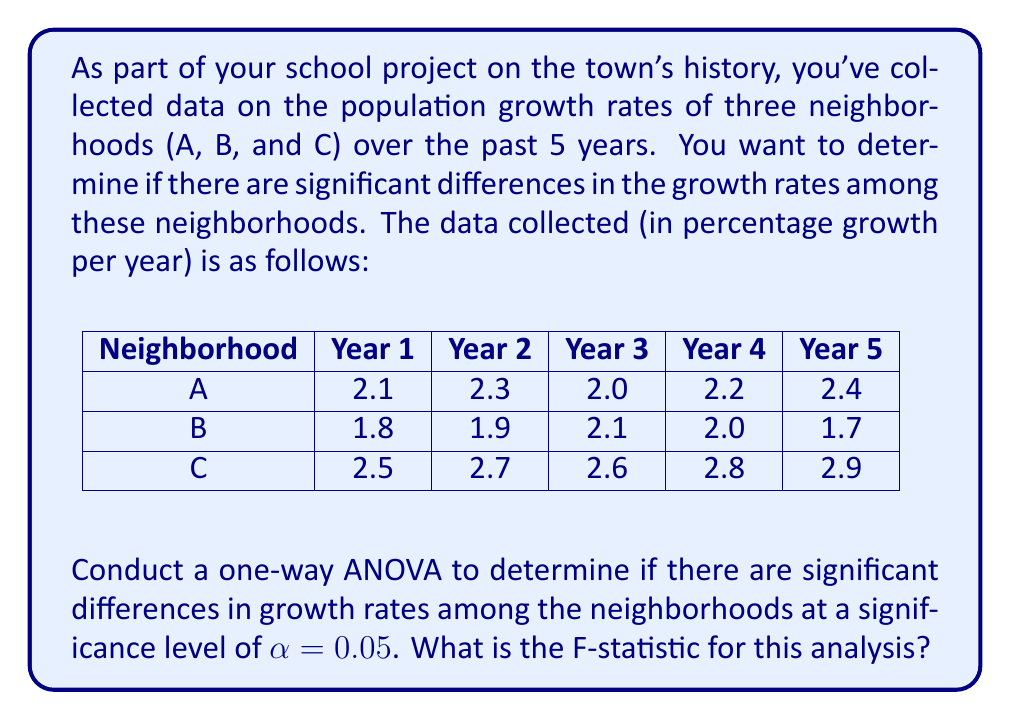Can you solve this math problem? To conduct a one-way ANOVA, we need to follow these steps:

1) Calculate the mean for each group (neighborhood):
   $\bar{x}_A = \frac{2.1 + 2.3 + 2.0 + 2.2 + 2.4}{5} = 2.2$
   $\bar{x}_B = \frac{1.8 + 1.9 + 2.1 + 2.0 + 1.7}{5} = 1.9$
   $\bar{x}_C = \frac{2.5 + 2.7 + 2.6 + 2.8 + 2.9}{5} = 2.7$

2) Calculate the grand mean:
   $\bar{x} = \frac{2.2 + 1.9 + 2.7}{3} = 2.267$

3) Calculate the Sum of Squares Between (SSB):
   $SSB = 5[(2.2 - 2.267)^2 + (1.9 - 2.267)^2 + (2.7 - 2.267)^2] = 1.6333$

4) Calculate the Sum of Squares Within (SSW):
   $SSW_A = (2.1 - 2.2)^2 + (2.3 - 2.2)^2 + (2.0 - 2.2)^2 + (2.2 - 2.2)^2 + (2.4 - 2.2)^2 = 0.12$
   $SSW_B = (1.8 - 1.9)^2 + (1.9 - 1.9)^2 + (2.1 - 1.9)^2 + (2.0 - 1.9)^2 + (1.7 - 1.9)^2 = 0.12$
   $SSW_C = (2.5 - 2.7)^2 + (2.7 - 2.7)^2 + (2.6 - 2.7)^2 + (2.8 - 2.7)^2 + (2.9 - 2.7)^2 = 0.12$
   $SSW = SSW_A + SSW_B + SSW_C = 0.36$

5) Calculate degrees of freedom:
   $df_{between} = k - 1 = 3 - 1 = 2$ (where k is the number of groups)
   $df_{within} = N - k = 15 - 3 = 12$ (where N is the total number of observations)

6) Calculate Mean Square Between (MSB) and Mean Square Within (MSW):
   $MSB = \frac{SSB}{df_{between}} = \frac{1.6333}{2} = 0.81665$
   $MSW = \frac{SSW}{df_{within}} = \frac{0.36}{12} = 0.03$

7) Calculate the F-statistic:
   $F = \frac{MSB}{MSW} = \frac{0.81665}{0.03} = 27.22$
Answer: $F = 27.22$ 